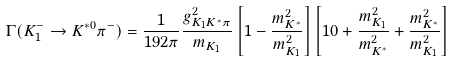<formula> <loc_0><loc_0><loc_500><loc_500>\Gamma ( K _ { 1 } ^ { - } \to K ^ { * 0 } \pi ^ { - } ) = \frac { 1 } { 1 9 2 \pi } \frac { g _ { K _ { 1 } K ^ { * } \pi } ^ { 2 } } { m _ { K _ { 1 } } } \left [ 1 - \frac { m _ { K ^ { * } } ^ { 2 } } { m _ { K _ { 1 } } ^ { 2 } } \right ] \left [ 1 0 + \frac { m _ { K _ { 1 } } ^ { 2 } } { m _ { K ^ { * } } ^ { 2 } } + \frac { m _ { K ^ { * } } ^ { 2 } } { m _ { K _ { 1 } } ^ { 2 } } \right ]</formula> 